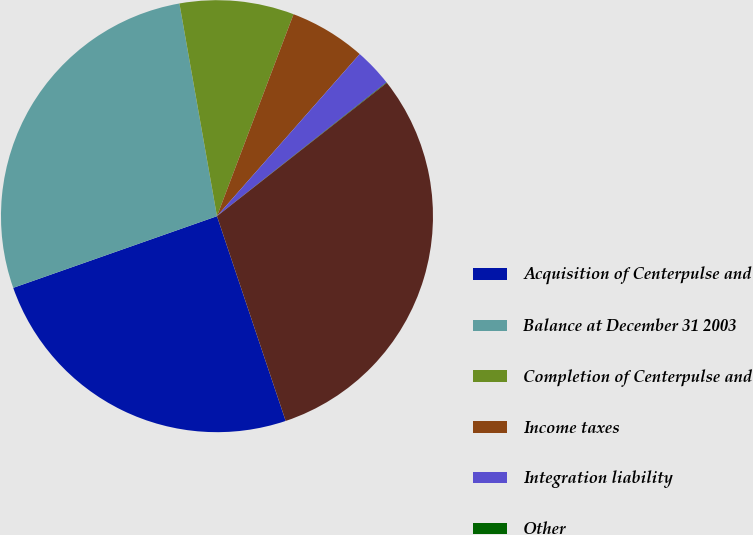Convert chart to OTSL. <chart><loc_0><loc_0><loc_500><loc_500><pie_chart><fcel>Acquisition of Centerpulse and<fcel>Balance at December 31 2003<fcel>Completion of Centerpulse and<fcel>Income taxes<fcel>Integration liability<fcel>Other<fcel>Balance at December 31 2004<nl><fcel>24.77%<fcel>27.6%<fcel>8.55%<fcel>5.72%<fcel>2.88%<fcel>0.04%<fcel>30.44%<nl></chart> 